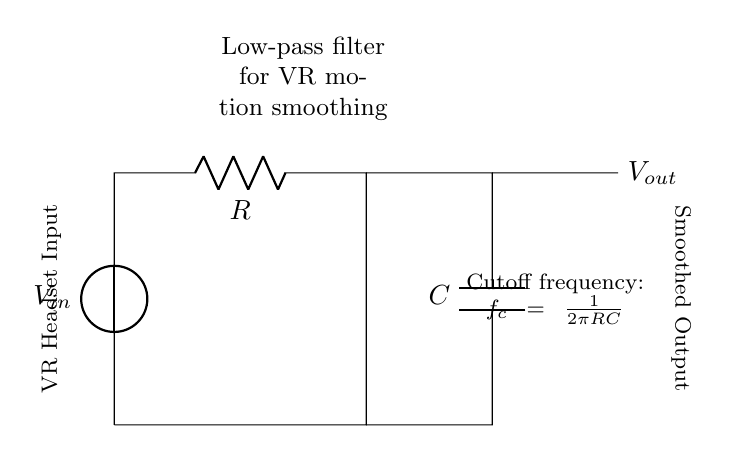What is the input voltage in this circuit? The input voltage is labeled as V_in. Based on typical circuit conventions, it can represent the voltage applied into the circuit.
Answer: V_in What type of filter is represented by this circuit? This circuit represents a low-pass filter, which is indicated by the arrangement of the resistor (R) and capacitor (C) in series. This configuration allows low-frequency signals to pass while attenuating high-frequency signals.
Answer: Low-pass filter What is the function of the capacitor in this circuit? The capacitor in this circuit works to smooth out rapid changes in voltage, effectively filtering high-frequency noise and allowing for gradual changes to be passed as output. Hence, it plays a crucial role in motion smoothing for signal processing.
Answer: Smoothing What is the cutoff frequency formula shown in the diagram? The cutoff frequency formula displayed in the diagram is f_c = 1/(2πRC). This indicates how the cutoff frequency depends on the values of resistance (R) and capacitance (C). It helps to determine at which frequency the output voltage drops to 70.7% of the input voltage.
Answer: f_c = 1/(2πRC) What does V_out represent in the circuit? V_out, labeled at the output side of the capacitor, represents the smoothed output voltage after passing through the low-pass filter. It indicates the voltage that is fed to the next stage in the circuit or system, in this case, the VR headset.
Answer: Smoothed Output How do R and C values affect filtering? R and C values directly affect the cutoff frequency (f_c) of the low-pass filter. By increasing R or C, the cutoff frequency decreases, allowing for more low frequencies to pass while blocking higher frequencies. Conversely, decreasing R or C raises the cutoff frequency, which can allow more high frequencies through.
Answer: They determine cutoff frequency 